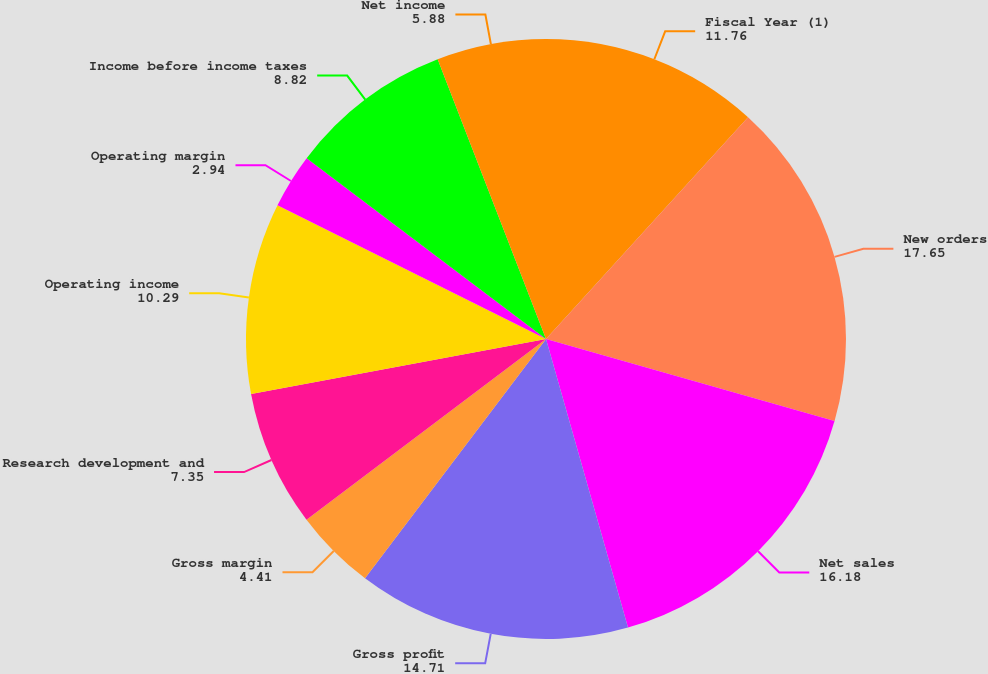Convert chart to OTSL. <chart><loc_0><loc_0><loc_500><loc_500><pie_chart><fcel>Fiscal Year (1)<fcel>New orders<fcel>Net sales<fcel>Gross profit<fcel>Gross margin<fcel>Research development and<fcel>Operating income<fcel>Operating margin<fcel>Income before income taxes<fcel>Net income<nl><fcel>11.76%<fcel>17.65%<fcel>16.18%<fcel>14.71%<fcel>4.41%<fcel>7.35%<fcel>10.29%<fcel>2.94%<fcel>8.82%<fcel>5.88%<nl></chart> 